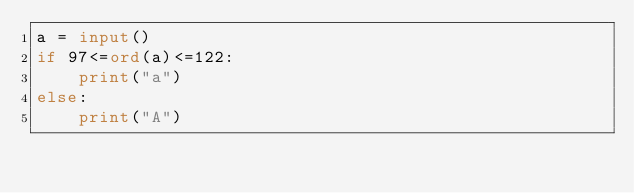<code> <loc_0><loc_0><loc_500><loc_500><_Python_>a = input()
if 97<=ord(a)<=122:
    print("a")
else:
    print("A")</code> 